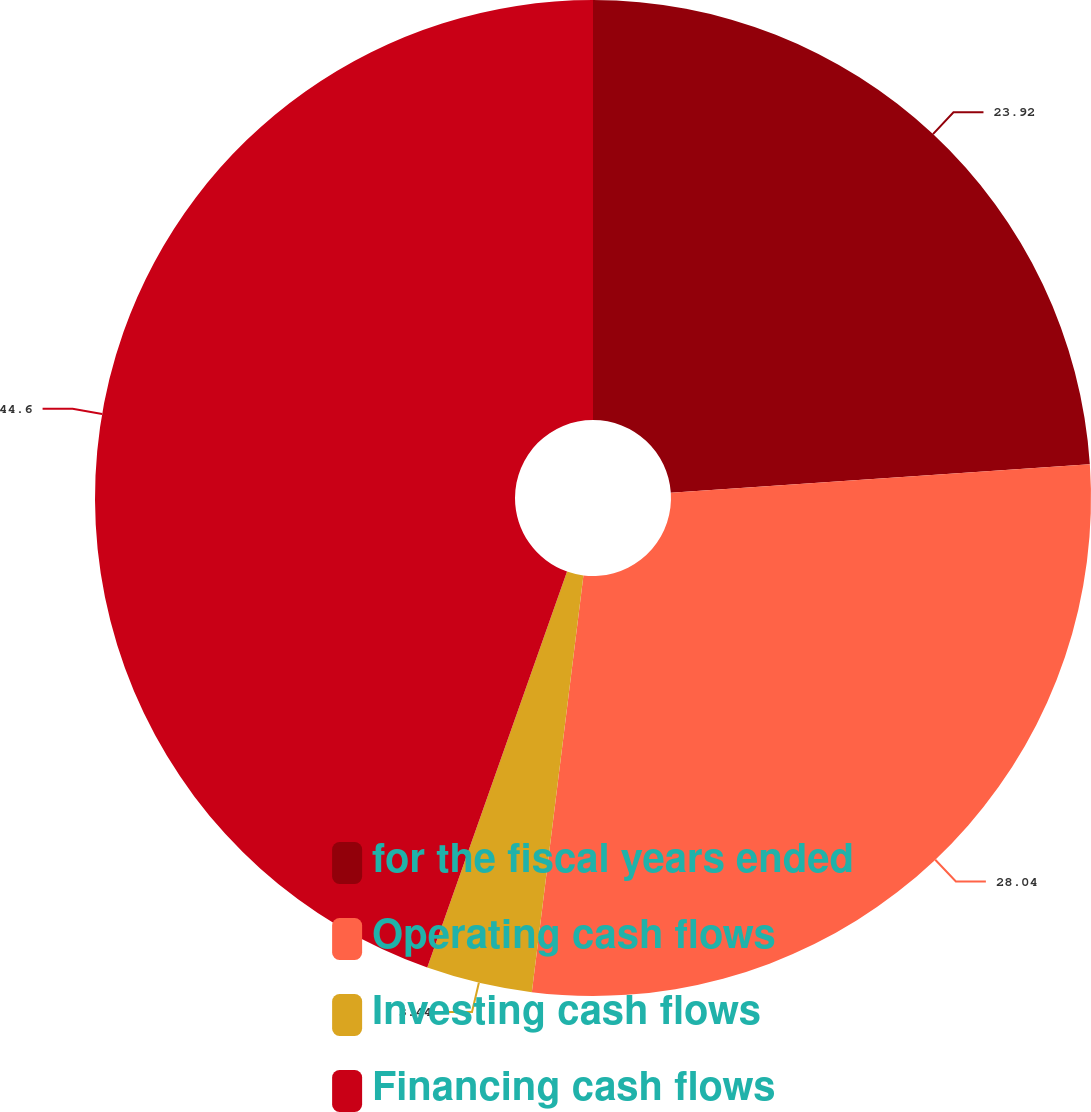Convert chart. <chart><loc_0><loc_0><loc_500><loc_500><pie_chart><fcel>for the fiscal years ended<fcel>Operating cash flows<fcel>Investing cash flows<fcel>Financing cash flows<nl><fcel>23.92%<fcel>28.04%<fcel>3.44%<fcel>44.6%<nl></chart> 